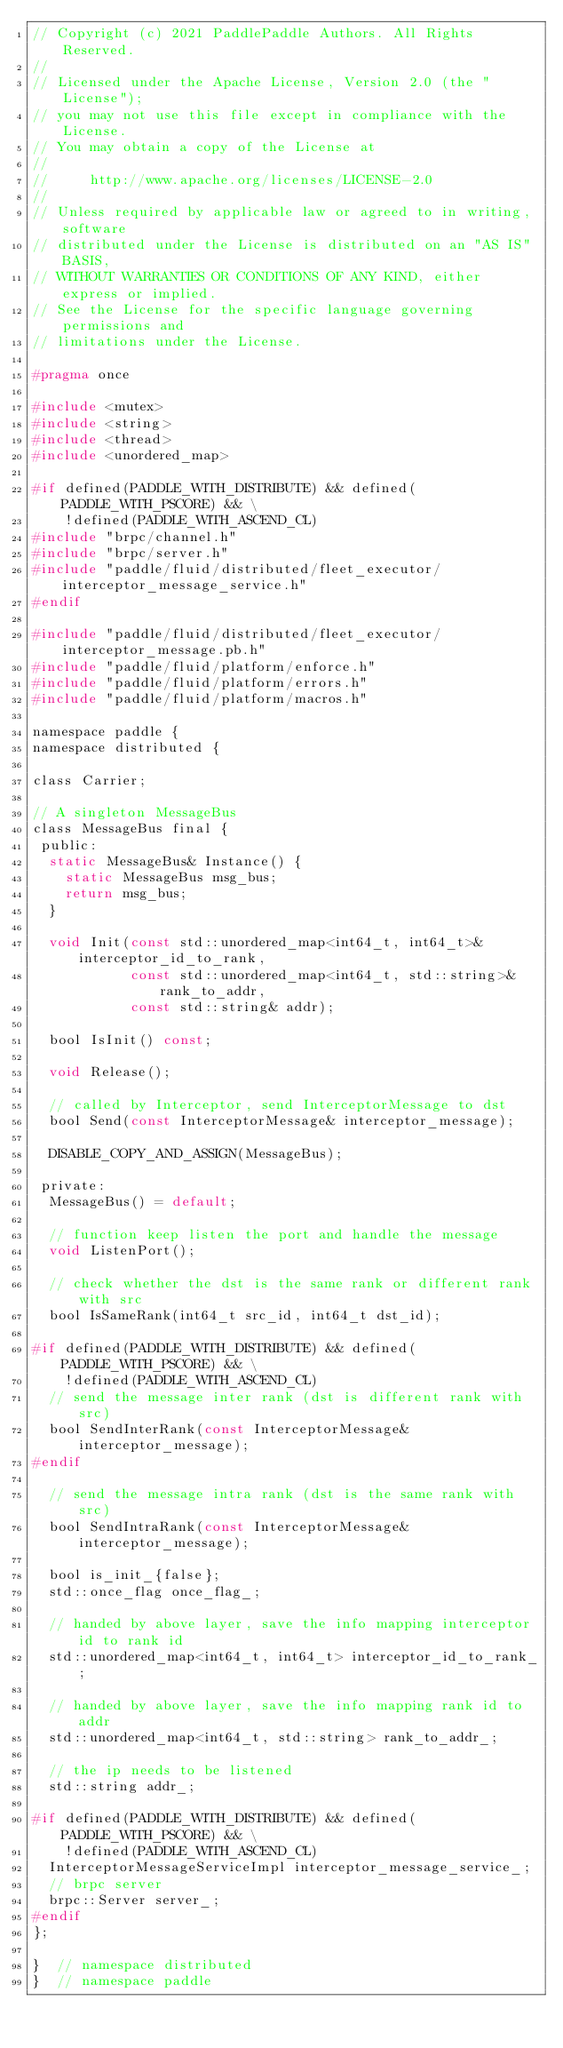Convert code to text. <code><loc_0><loc_0><loc_500><loc_500><_C_>// Copyright (c) 2021 PaddlePaddle Authors. All Rights Reserved.
//
// Licensed under the Apache License, Version 2.0 (the "License");
// you may not use this file except in compliance with the License.
// You may obtain a copy of the License at
//
//     http://www.apache.org/licenses/LICENSE-2.0
//
// Unless required by applicable law or agreed to in writing, software
// distributed under the License is distributed on an "AS IS" BASIS,
// WITHOUT WARRANTIES OR CONDITIONS OF ANY KIND, either express or implied.
// See the License for the specific language governing permissions and
// limitations under the License.

#pragma once

#include <mutex>
#include <string>
#include <thread>
#include <unordered_map>

#if defined(PADDLE_WITH_DISTRIBUTE) && defined(PADDLE_WITH_PSCORE) && \
    !defined(PADDLE_WITH_ASCEND_CL)
#include "brpc/channel.h"
#include "brpc/server.h"
#include "paddle/fluid/distributed/fleet_executor/interceptor_message_service.h"
#endif

#include "paddle/fluid/distributed/fleet_executor/interceptor_message.pb.h"
#include "paddle/fluid/platform/enforce.h"
#include "paddle/fluid/platform/errors.h"
#include "paddle/fluid/platform/macros.h"

namespace paddle {
namespace distributed {

class Carrier;

// A singleton MessageBus
class MessageBus final {
 public:
  static MessageBus& Instance() {
    static MessageBus msg_bus;
    return msg_bus;
  }

  void Init(const std::unordered_map<int64_t, int64_t>& interceptor_id_to_rank,
            const std::unordered_map<int64_t, std::string>& rank_to_addr,
            const std::string& addr);

  bool IsInit() const;

  void Release();

  // called by Interceptor, send InterceptorMessage to dst
  bool Send(const InterceptorMessage& interceptor_message);

  DISABLE_COPY_AND_ASSIGN(MessageBus);

 private:
  MessageBus() = default;

  // function keep listen the port and handle the message
  void ListenPort();

  // check whether the dst is the same rank or different rank with src
  bool IsSameRank(int64_t src_id, int64_t dst_id);

#if defined(PADDLE_WITH_DISTRIBUTE) && defined(PADDLE_WITH_PSCORE) && \
    !defined(PADDLE_WITH_ASCEND_CL)
  // send the message inter rank (dst is different rank with src)
  bool SendInterRank(const InterceptorMessage& interceptor_message);
#endif

  // send the message intra rank (dst is the same rank with src)
  bool SendIntraRank(const InterceptorMessage& interceptor_message);

  bool is_init_{false};
  std::once_flag once_flag_;

  // handed by above layer, save the info mapping interceptor id to rank id
  std::unordered_map<int64_t, int64_t> interceptor_id_to_rank_;

  // handed by above layer, save the info mapping rank id to addr
  std::unordered_map<int64_t, std::string> rank_to_addr_;

  // the ip needs to be listened
  std::string addr_;

#if defined(PADDLE_WITH_DISTRIBUTE) && defined(PADDLE_WITH_PSCORE) && \
    !defined(PADDLE_WITH_ASCEND_CL)
  InterceptorMessageServiceImpl interceptor_message_service_;
  // brpc server
  brpc::Server server_;
#endif
};

}  // namespace distributed
}  // namespace paddle
</code> 